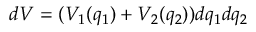<formula> <loc_0><loc_0><loc_500><loc_500>d V = ( V _ { 1 } ( q _ { 1 } ) + V _ { 2 } ( q _ { 2 } ) ) d q _ { 1 } d q _ { 2 }</formula> 